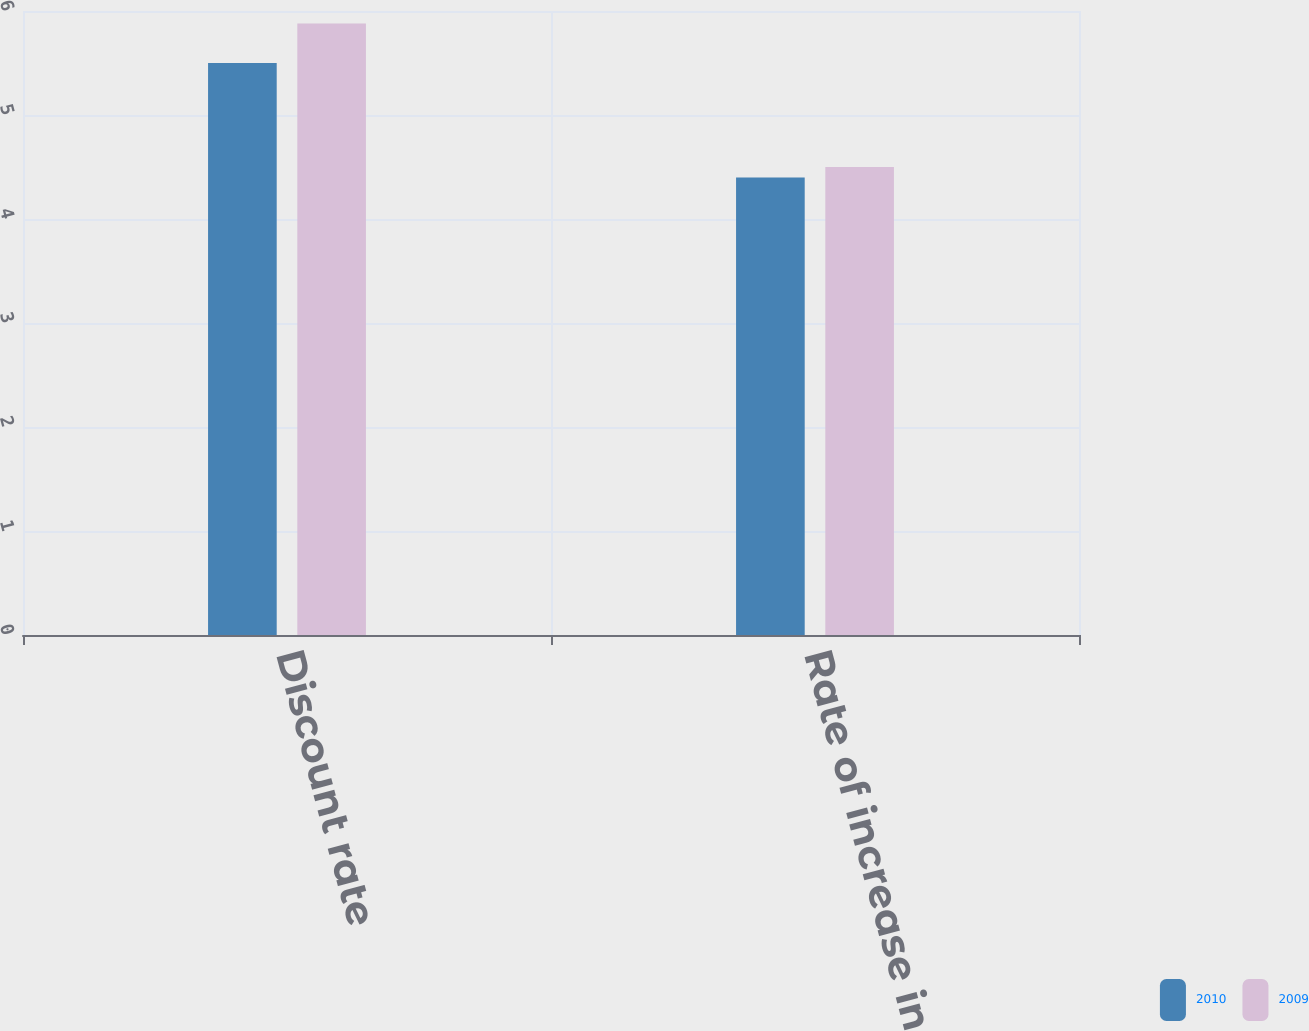<chart> <loc_0><loc_0><loc_500><loc_500><stacked_bar_chart><ecel><fcel>Discount rate<fcel>Rate of increase in future<nl><fcel>2010<fcel>5.5<fcel>4.4<nl><fcel>2009<fcel>5.88<fcel>4.5<nl></chart> 